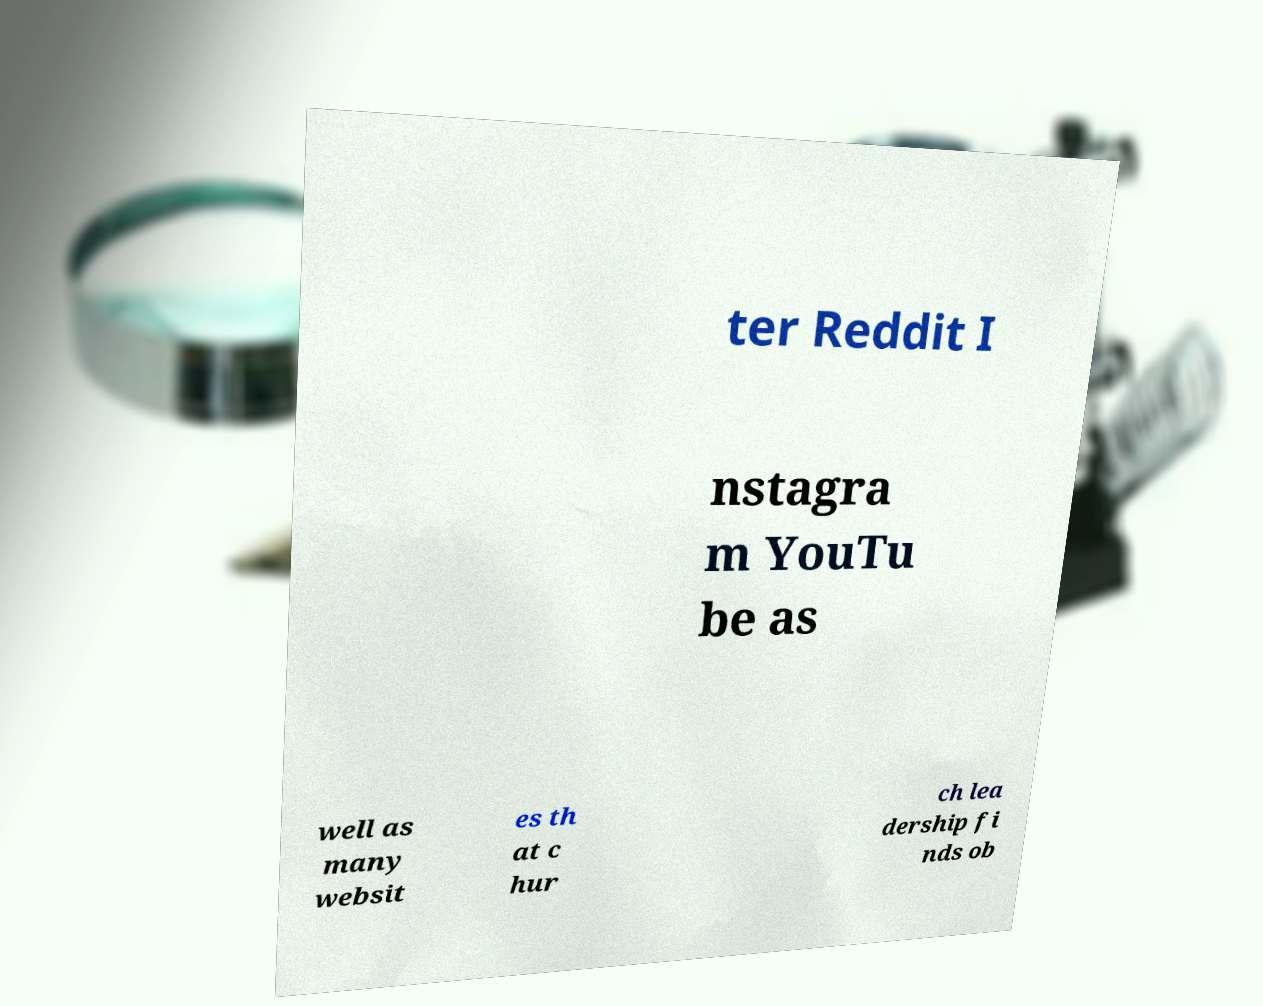Please read and relay the text visible in this image. What does it say? ter Reddit I nstagra m YouTu be as well as many websit es th at c hur ch lea dership fi nds ob 